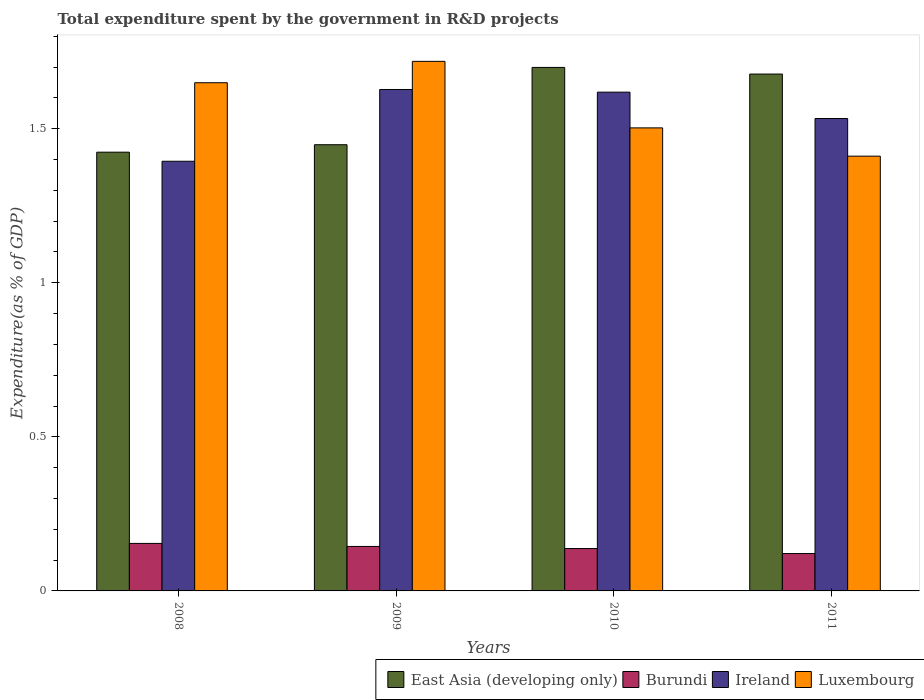How many different coloured bars are there?
Keep it short and to the point. 4. Are the number of bars on each tick of the X-axis equal?
Keep it short and to the point. Yes. What is the total expenditure spent by the government in R&D projects in Luxembourg in 2010?
Your answer should be very brief. 1.5. Across all years, what is the maximum total expenditure spent by the government in R&D projects in East Asia (developing only)?
Offer a terse response. 1.7. Across all years, what is the minimum total expenditure spent by the government in R&D projects in Ireland?
Provide a succinct answer. 1.39. In which year was the total expenditure spent by the government in R&D projects in East Asia (developing only) maximum?
Offer a very short reply. 2010. What is the total total expenditure spent by the government in R&D projects in Luxembourg in the graph?
Keep it short and to the point. 6.28. What is the difference between the total expenditure spent by the government in R&D projects in Luxembourg in 2008 and that in 2011?
Keep it short and to the point. 0.24. What is the difference between the total expenditure spent by the government in R&D projects in Ireland in 2008 and the total expenditure spent by the government in R&D projects in East Asia (developing only) in 2010?
Your answer should be very brief. -0.3. What is the average total expenditure spent by the government in R&D projects in Ireland per year?
Ensure brevity in your answer.  1.54. In the year 2011, what is the difference between the total expenditure spent by the government in R&D projects in East Asia (developing only) and total expenditure spent by the government in R&D projects in Luxembourg?
Offer a terse response. 0.27. In how many years, is the total expenditure spent by the government in R&D projects in Luxembourg greater than 0.8 %?
Provide a succinct answer. 4. What is the ratio of the total expenditure spent by the government in R&D projects in Burundi in 2010 to that in 2011?
Offer a very short reply. 1.13. Is the total expenditure spent by the government in R&D projects in Burundi in 2010 less than that in 2011?
Provide a short and direct response. No. What is the difference between the highest and the second highest total expenditure spent by the government in R&D projects in East Asia (developing only)?
Your answer should be very brief. 0.02. What is the difference between the highest and the lowest total expenditure spent by the government in R&D projects in Burundi?
Provide a succinct answer. 0.03. In how many years, is the total expenditure spent by the government in R&D projects in Ireland greater than the average total expenditure spent by the government in R&D projects in Ireland taken over all years?
Give a very brief answer. 2. What does the 4th bar from the left in 2009 represents?
Offer a very short reply. Luxembourg. What does the 1st bar from the right in 2010 represents?
Provide a succinct answer. Luxembourg. Is it the case that in every year, the sum of the total expenditure spent by the government in R&D projects in Ireland and total expenditure spent by the government in R&D projects in Burundi is greater than the total expenditure spent by the government in R&D projects in Luxembourg?
Your answer should be very brief. No. How many years are there in the graph?
Provide a succinct answer. 4. Are the values on the major ticks of Y-axis written in scientific E-notation?
Offer a terse response. No. Does the graph contain any zero values?
Offer a terse response. No. Where does the legend appear in the graph?
Offer a very short reply. Bottom right. How many legend labels are there?
Your answer should be very brief. 4. What is the title of the graph?
Your answer should be very brief. Total expenditure spent by the government in R&D projects. What is the label or title of the X-axis?
Ensure brevity in your answer.  Years. What is the label or title of the Y-axis?
Make the answer very short. Expenditure(as % of GDP). What is the Expenditure(as % of GDP) in East Asia (developing only) in 2008?
Make the answer very short. 1.42. What is the Expenditure(as % of GDP) of Burundi in 2008?
Offer a very short reply. 0.15. What is the Expenditure(as % of GDP) in Ireland in 2008?
Offer a terse response. 1.39. What is the Expenditure(as % of GDP) in Luxembourg in 2008?
Ensure brevity in your answer.  1.65. What is the Expenditure(as % of GDP) of East Asia (developing only) in 2009?
Provide a short and direct response. 1.45. What is the Expenditure(as % of GDP) of Burundi in 2009?
Your answer should be compact. 0.14. What is the Expenditure(as % of GDP) of Ireland in 2009?
Keep it short and to the point. 1.63. What is the Expenditure(as % of GDP) in Luxembourg in 2009?
Ensure brevity in your answer.  1.72. What is the Expenditure(as % of GDP) in East Asia (developing only) in 2010?
Give a very brief answer. 1.7. What is the Expenditure(as % of GDP) in Burundi in 2010?
Give a very brief answer. 0.14. What is the Expenditure(as % of GDP) in Ireland in 2010?
Your response must be concise. 1.62. What is the Expenditure(as % of GDP) of Luxembourg in 2010?
Ensure brevity in your answer.  1.5. What is the Expenditure(as % of GDP) of East Asia (developing only) in 2011?
Your response must be concise. 1.68. What is the Expenditure(as % of GDP) in Burundi in 2011?
Give a very brief answer. 0.12. What is the Expenditure(as % of GDP) in Ireland in 2011?
Your answer should be very brief. 1.53. What is the Expenditure(as % of GDP) in Luxembourg in 2011?
Give a very brief answer. 1.41. Across all years, what is the maximum Expenditure(as % of GDP) of East Asia (developing only)?
Keep it short and to the point. 1.7. Across all years, what is the maximum Expenditure(as % of GDP) of Burundi?
Your answer should be compact. 0.15. Across all years, what is the maximum Expenditure(as % of GDP) of Ireland?
Your answer should be compact. 1.63. Across all years, what is the maximum Expenditure(as % of GDP) in Luxembourg?
Provide a succinct answer. 1.72. Across all years, what is the minimum Expenditure(as % of GDP) of East Asia (developing only)?
Ensure brevity in your answer.  1.42. Across all years, what is the minimum Expenditure(as % of GDP) in Burundi?
Ensure brevity in your answer.  0.12. Across all years, what is the minimum Expenditure(as % of GDP) in Ireland?
Ensure brevity in your answer.  1.39. Across all years, what is the minimum Expenditure(as % of GDP) in Luxembourg?
Provide a short and direct response. 1.41. What is the total Expenditure(as % of GDP) in East Asia (developing only) in the graph?
Offer a very short reply. 6.25. What is the total Expenditure(as % of GDP) of Burundi in the graph?
Provide a succinct answer. 0.56. What is the total Expenditure(as % of GDP) of Ireland in the graph?
Give a very brief answer. 6.17. What is the total Expenditure(as % of GDP) in Luxembourg in the graph?
Make the answer very short. 6.28. What is the difference between the Expenditure(as % of GDP) of East Asia (developing only) in 2008 and that in 2009?
Ensure brevity in your answer.  -0.02. What is the difference between the Expenditure(as % of GDP) of Burundi in 2008 and that in 2009?
Give a very brief answer. 0.01. What is the difference between the Expenditure(as % of GDP) of Ireland in 2008 and that in 2009?
Offer a terse response. -0.23. What is the difference between the Expenditure(as % of GDP) in Luxembourg in 2008 and that in 2009?
Ensure brevity in your answer.  -0.07. What is the difference between the Expenditure(as % of GDP) in East Asia (developing only) in 2008 and that in 2010?
Provide a succinct answer. -0.28. What is the difference between the Expenditure(as % of GDP) in Burundi in 2008 and that in 2010?
Your answer should be compact. 0.02. What is the difference between the Expenditure(as % of GDP) of Ireland in 2008 and that in 2010?
Your response must be concise. -0.22. What is the difference between the Expenditure(as % of GDP) of Luxembourg in 2008 and that in 2010?
Your response must be concise. 0.15. What is the difference between the Expenditure(as % of GDP) of East Asia (developing only) in 2008 and that in 2011?
Give a very brief answer. -0.25. What is the difference between the Expenditure(as % of GDP) of Burundi in 2008 and that in 2011?
Offer a terse response. 0.03. What is the difference between the Expenditure(as % of GDP) in Ireland in 2008 and that in 2011?
Keep it short and to the point. -0.14. What is the difference between the Expenditure(as % of GDP) in Luxembourg in 2008 and that in 2011?
Make the answer very short. 0.24. What is the difference between the Expenditure(as % of GDP) in East Asia (developing only) in 2009 and that in 2010?
Provide a short and direct response. -0.25. What is the difference between the Expenditure(as % of GDP) of Burundi in 2009 and that in 2010?
Provide a succinct answer. 0.01. What is the difference between the Expenditure(as % of GDP) in Ireland in 2009 and that in 2010?
Ensure brevity in your answer.  0.01. What is the difference between the Expenditure(as % of GDP) in Luxembourg in 2009 and that in 2010?
Offer a terse response. 0.22. What is the difference between the Expenditure(as % of GDP) of East Asia (developing only) in 2009 and that in 2011?
Provide a short and direct response. -0.23. What is the difference between the Expenditure(as % of GDP) in Burundi in 2009 and that in 2011?
Give a very brief answer. 0.02. What is the difference between the Expenditure(as % of GDP) in Ireland in 2009 and that in 2011?
Your response must be concise. 0.09. What is the difference between the Expenditure(as % of GDP) of Luxembourg in 2009 and that in 2011?
Keep it short and to the point. 0.31. What is the difference between the Expenditure(as % of GDP) in East Asia (developing only) in 2010 and that in 2011?
Ensure brevity in your answer.  0.02. What is the difference between the Expenditure(as % of GDP) in Burundi in 2010 and that in 2011?
Your response must be concise. 0.02. What is the difference between the Expenditure(as % of GDP) of Ireland in 2010 and that in 2011?
Offer a very short reply. 0.09. What is the difference between the Expenditure(as % of GDP) of Luxembourg in 2010 and that in 2011?
Your answer should be compact. 0.09. What is the difference between the Expenditure(as % of GDP) of East Asia (developing only) in 2008 and the Expenditure(as % of GDP) of Burundi in 2009?
Offer a terse response. 1.28. What is the difference between the Expenditure(as % of GDP) in East Asia (developing only) in 2008 and the Expenditure(as % of GDP) in Ireland in 2009?
Offer a very short reply. -0.2. What is the difference between the Expenditure(as % of GDP) in East Asia (developing only) in 2008 and the Expenditure(as % of GDP) in Luxembourg in 2009?
Your answer should be compact. -0.29. What is the difference between the Expenditure(as % of GDP) of Burundi in 2008 and the Expenditure(as % of GDP) of Ireland in 2009?
Provide a succinct answer. -1.47. What is the difference between the Expenditure(as % of GDP) of Burundi in 2008 and the Expenditure(as % of GDP) of Luxembourg in 2009?
Your answer should be very brief. -1.56. What is the difference between the Expenditure(as % of GDP) of Ireland in 2008 and the Expenditure(as % of GDP) of Luxembourg in 2009?
Your answer should be very brief. -0.32. What is the difference between the Expenditure(as % of GDP) in East Asia (developing only) in 2008 and the Expenditure(as % of GDP) in Burundi in 2010?
Make the answer very short. 1.29. What is the difference between the Expenditure(as % of GDP) in East Asia (developing only) in 2008 and the Expenditure(as % of GDP) in Ireland in 2010?
Your answer should be very brief. -0.19. What is the difference between the Expenditure(as % of GDP) of East Asia (developing only) in 2008 and the Expenditure(as % of GDP) of Luxembourg in 2010?
Your response must be concise. -0.08. What is the difference between the Expenditure(as % of GDP) in Burundi in 2008 and the Expenditure(as % of GDP) in Ireland in 2010?
Ensure brevity in your answer.  -1.46. What is the difference between the Expenditure(as % of GDP) of Burundi in 2008 and the Expenditure(as % of GDP) of Luxembourg in 2010?
Offer a very short reply. -1.35. What is the difference between the Expenditure(as % of GDP) in Ireland in 2008 and the Expenditure(as % of GDP) in Luxembourg in 2010?
Your response must be concise. -0.11. What is the difference between the Expenditure(as % of GDP) of East Asia (developing only) in 2008 and the Expenditure(as % of GDP) of Burundi in 2011?
Offer a very short reply. 1.3. What is the difference between the Expenditure(as % of GDP) in East Asia (developing only) in 2008 and the Expenditure(as % of GDP) in Ireland in 2011?
Give a very brief answer. -0.11. What is the difference between the Expenditure(as % of GDP) in East Asia (developing only) in 2008 and the Expenditure(as % of GDP) in Luxembourg in 2011?
Provide a short and direct response. 0.01. What is the difference between the Expenditure(as % of GDP) of Burundi in 2008 and the Expenditure(as % of GDP) of Ireland in 2011?
Your answer should be compact. -1.38. What is the difference between the Expenditure(as % of GDP) of Burundi in 2008 and the Expenditure(as % of GDP) of Luxembourg in 2011?
Keep it short and to the point. -1.26. What is the difference between the Expenditure(as % of GDP) of Ireland in 2008 and the Expenditure(as % of GDP) of Luxembourg in 2011?
Your response must be concise. -0.02. What is the difference between the Expenditure(as % of GDP) of East Asia (developing only) in 2009 and the Expenditure(as % of GDP) of Burundi in 2010?
Ensure brevity in your answer.  1.31. What is the difference between the Expenditure(as % of GDP) of East Asia (developing only) in 2009 and the Expenditure(as % of GDP) of Ireland in 2010?
Give a very brief answer. -0.17. What is the difference between the Expenditure(as % of GDP) in East Asia (developing only) in 2009 and the Expenditure(as % of GDP) in Luxembourg in 2010?
Offer a terse response. -0.05. What is the difference between the Expenditure(as % of GDP) in Burundi in 2009 and the Expenditure(as % of GDP) in Ireland in 2010?
Your answer should be compact. -1.47. What is the difference between the Expenditure(as % of GDP) in Burundi in 2009 and the Expenditure(as % of GDP) in Luxembourg in 2010?
Ensure brevity in your answer.  -1.36. What is the difference between the Expenditure(as % of GDP) of Ireland in 2009 and the Expenditure(as % of GDP) of Luxembourg in 2010?
Your answer should be very brief. 0.12. What is the difference between the Expenditure(as % of GDP) of East Asia (developing only) in 2009 and the Expenditure(as % of GDP) of Burundi in 2011?
Ensure brevity in your answer.  1.33. What is the difference between the Expenditure(as % of GDP) in East Asia (developing only) in 2009 and the Expenditure(as % of GDP) in Ireland in 2011?
Your response must be concise. -0.09. What is the difference between the Expenditure(as % of GDP) of East Asia (developing only) in 2009 and the Expenditure(as % of GDP) of Luxembourg in 2011?
Provide a short and direct response. 0.04. What is the difference between the Expenditure(as % of GDP) in Burundi in 2009 and the Expenditure(as % of GDP) in Ireland in 2011?
Ensure brevity in your answer.  -1.39. What is the difference between the Expenditure(as % of GDP) in Burundi in 2009 and the Expenditure(as % of GDP) in Luxembourg in 2011?
Provide a succinct answer. -1.27. What is the difference between the Expenditure(as % of GDP) in Ireland in 2009 and the Expenditure(as % of GDP) in Luxembourg in 2011?
Your answer should be compact. 0.22. What is the difference between the Expenditure(as % of GDP) in East Asia (developing only) in 2010 and the Expenditure(as % of GDP) in Burundi in 2011?
Your answer should be compact. 1.58. What is the difference between the Expenditure(as % of GDP) in East Asia (developing only) in 2010 and the Expenditure(as % of GDP) in Ireland in 2011?
Offer a terse response. 0.17. What is the difference between the Expenditure(as % of GDP) of East Asia (developing only) in 2010 and the Expenditure(as % of GDP) of Luxembourg in 2011?
Offer a very short reply. 0.29. What is the difference between the Expenditure(as % of GDP) in Burundi in 2010 and the Expenditure(as % of GDP) in Ireland in 2011?
Offer a terse response. -1.4. What is the difference between the Expenditure(as % of GDP) in Burundi in 2010 and the Expenditure(as % of GDP) in Luxembourg in 2011?
Your response must be concise. -1.27. What is the difference between the Expenditure(as % of GDP) in Ireland in 2010 and the Expenditure(as % of GDP) in Luxembourg in 2011?
Your answer should be very brief. 0.21. What is the average Expenditure(as % of GDP) of East Asia (developing only) per year?
Your answer should be compact. 1.56. What is the average Expenditure(as % of GDP) in Burundi per year?
Offer a terse response. 0.14. What is the average Expenditure(as % of GDP) of Ireland per year?
Offer a terse response. 1.54. What is the average Expenditure(as % of GDP) of Luxembourg per year?
Give a very brief answer. 1.57. In the year 2008, what is the difference between the Expenditure(as % of GDP) of East Asia (developing only) and Expenditure(as % of GDP) of Burundi?
Keep it short and to the point. 1.27. In the year 2008, what is the difference between the Expenditure(as % of GDP) in East Asia (developing only) and Expenditure(as % of GDP) in Ireland?
Make the answer very short. 0.03. In the year 2008, what is the difference between the Expenditure(as % of GDP) in East Asia (developing only) and Expenditure(as % of GDP) in Luxembourg?
Keep it short and to the point. -0.23. In the year 2008, what is the difference between the Expenditure(as % of GDP) of Burundi and Expenditure(as % of GDP) of Ireland?
Your answer should be very brief. -1.24. In the year 2008, what is the difference between the Expenditure(as % of GDP) in Burundi and Expenditure(as % of GDP) in Luxembourg?
Provide a succinct answer. -1.5. In the year 2008, what is the difference between the Expenditure(as % of GDP) in Ireland and Expenditure(as % of GDP) in Luxembourg?
Make the answer very short. -0.25. In the year 2009, what is the difference between the Expenditure(as % of GDP) of East Asia (developing only) and Expenditure(as % of GDP) of Burundi?
Ensure brevity in your answer.  1.3. In the year 2009, what is the difference between the Expenditure(as % of GDP) of East Asia (developing only) and Expenditure(as % of GDP) of Ireland?
Provide a succinct answer. -0.18. In the year 2009, what is the difference between the Expenditure(as % of GDP) in East Asia (developing only) and Expenditure(as % of GDP) in Luxembourg?
Offer a terse response. -0.27. In the year 2009, what is the difference between the Expenditure(as % of GDP) in Burundi and Expenditure(as % of GDP) in Ireland?
Make the answer very short. -1.48. In the year 2009, what is the difference between the Expenditure(as % of GDP) in Burundi and Expenditure(as % of GDP) in Luxembourg?
Your answer should be compact. -1.57. In the year 2009, what is the difference between the Expenditure(as % of GDP) in Ireland and Expenditure(as % of GDP) in Luxembourg?
Keep it short and to the point. -0.09. In the year 2010, what is the difference between the Expenditure(as % of GDP) in East Asia (developing only) and Expenditure(as % of GDP) in Burundi?
Your response must be concise. 1.56. In the year 2010, what is the difference between the Expenditure(as % of GDP) of East Asia (developing only) and Expenditure(as % of GDP) of Ireland?
Give a very brief answer. 0.08. In the year 2010, what is the difference between the Expenditure(as % of GDP) of East Asia (developing only) and Expenditure(as % of GDP) of Luxembourg?
Your answer should be very brief. 0.2. In the year 2010, what is the difference between the Expenditure(as % of GDP) in Burundi and Expenditure(as % of GDP) in Ireland?
Your answer should be compact. -1.48. In the year 2010, what is the difference between the Expenditure(as % of GDP) of Burundi and Expenditure(as % of GDP) of Luxembourg?
Your answer should be very brief. -1.37. In the year 2010, what is the difference between the Expenditure(as % of GDP) in Ireland and Expenditure(as % of GDP) in Luxembourg?
Your response must be concise. 0.12. In the year 2011, what is the difference between the Expenditure(as % of GDP) of East Asia (developing only) and Expenditure(as % of GDP) of Burundi?
Offer a terse response. 1.56. In the year 2011, what is the difference between the Expenditure(as % of GDP) in East Asia (developing only) and Expenditure(as % of GDP) in Ireland?
Offer a very short reply. 0.14. In the year 2011, what is the difference between the Expenditure(as % of GDP) of East Asia (developing only) and Expenditure(as % of GDP) of Luxembourg?
Your answer should be compact. 0.27. In the year 2011, what is the difference between the Expenditure(as % of GDP) of Burundi and Expenditure(as % of GDP) of Ireland?
Your response must be concise. -1.41. In the year 2011, what is the difference between the Expenditure(as % of GDP) of Burundi and Expenditure(as % of GDP) of Luxembourg?
Make the answer very short. -1.29. In the year 2011, what is the difference between the Expenditure(as % of GDP) of Ireland and Expenditure(as % of GDP) of Luxembourg?
Your answer should be compact. 0.12. What is the ratio of the Expenditure(as % of GDP) of East Asia (developing only) in 2008 to that in 2009?
Offer a very short reply. 0.98. What is the ratio of the Expenditure(as % of GDP) in Burundi in 2008 to that in 2009?
Your answer should be compact. 1.07. What is the ratio of the Expenditure(as % of GDP) of Ireland in 2008 to that in 2009?
Offer a very short reply. 0.86. What is the ratio of the Expenditure(as % of GDP) of Luxembourg in 2008 to that in 2009?
Provide a short and direct response. 0.96. What is the ratio of the Expenditure(as % of GDP) of East Asia (developing only) in 2008 to that in 2010?
Your answer should be very brief. 0.84. What is the ratio of the Expenditure(as % of GDP) of Burundi in 2008 to that in 2010?
Your answer should be very brief. 1.12. What is the ratio of the Expenditure(as % of GDP) in Ireland in 2008 to that in 2010?
Your response must be concise. 0.86. What is the ratio of the Expenditure(as % of GDP) of Luxembourg in 2008 to that in 2010?
Offer a terse response. 1.1. What is the ratio of the Expenditure(as % of GDP) in East Asia (developing only) in 2008 to that in 2011?
Provide a short and direct response. 0.85. What is the ratio of the Expenditure(as % of GDP) in Burundi in 2008 to that in 2011?
Provide a short and direct response. 1.27. What is the ratio of the Expenditure(as % of GDP) in Ireland in 2008 to that in 2011?
Keep it short and to the point. 0.91. What is the ratio of the Expenditure(as % of GDP) of Luxembourg in 2008 to that in 2011?
Make the answer very short. 1.17. What is the ratio of the Expenditure(as % of GDP) of East Asia (developing only) in 2009 to that in 2010?
Provide a short and direct response. 0.85. What is the ratio of the Expenditure(as % of GDP) of Burundi in 2009 to that in 2010?
Your answer should be very brief. 1.05. What is the ratio of the Expenditure(as % of GDP) of Luxembourg in 2009 to that in 2010?
Provide a succinct answer. 1.14. What is the ratio of the Expenditure(as % of GDP) in East Asia (developing only) in 2009 to that in 2011?
Your answer should be compact. 0.86. What is the ratio of the Expenditure(as % of GDP) of Burundi in 2009 to that in 2011?
Your answer should be very brief. 1.19. What is the ratio of the Expenditure(as % of GDP) of Ireland in 2009 to that in 2011?
Ensure brevity in your answer.  1.06. What is the ratio of the Expenditure(as % of GDP) of Luxembourg in 2009 to that in 2011?
Offer a very short reply. 1.22. What is the ratio of the Expenditure(as % of GDP) of East Asia (developing only) in 2010 to that in 2011?
Provide a succinct answer. 1.01. What is the ratio of the Expenditure(as % of GDP) in Burundi in 2010 to that in 2011?
Make the answer very short. 1.13. What is the ratio of the Expenditure(as % of GDP) of Ireland in 2010 to that in 2011?
Your answer should be very brief. 1.06. What is the ratio of the Expenditure(as % of GDP) of Luxembourg in 2010 to that in 2011?
Offer a very short reply. 1.06. What is the difference between the highest and the second highest Expenditure(as % of GDP) of East Asia (developing only)?
Give a very brief answer. 0.02. What is the difference between the highest and the second highest Expenditure(as % of GDP) in Burundi?
Your answer should be very brief. 0.01. What is the difference between the highest and the second highest Expenditure(as % of GDP) of Ireland?
Keep it short and to the point. 0.01. What is the difference between the highest and the second highest Expenditure(as % of GDP) in Luxembourg?
Offer a very short reply. 0.07. What is the difference between the highest and the lowest Expenditure(as % of GDP) of East Asia (developing only)?
Your answer should be very brief. 0.28. What is the difference between the highest and the lowest Expenditure(as % of GDP) in Burundi?
Your answer should be very brief. 0.03. What is the difference between the highest and the lowest Expenditure(as % of GDP) in Ireland?
Offer a terse response. 0.23. What is the difference between the highest and the lowest Expenditure(as % of GDP) in Luxembourg?
Your answer should be very brief. 0.31. 